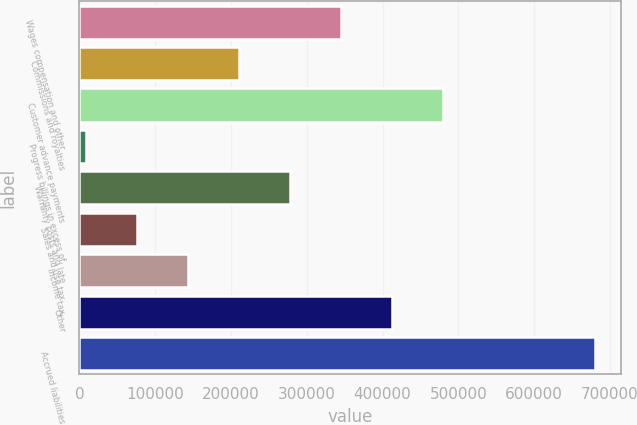Convert chart. <chart><loc_0><loc_0><loc_500><loc_500><bar_chart><fcel>Wages compensation and other<fcel>Commissions and royalties<fcel>Customer advance payments<fcel>Progress billings in excess of<fcel>Warranty costs and late<fcel>Sales and use tax<fcel>Income tax<fcel>Other<fcel>Accrued liabilities<nl><fcel>344852<fcel>210516<fcel>479186<fcel>9014<fcel>277684<fcel>76181.5<fcel>143349<fcel>412019<fcel>680689<nl></chart> 